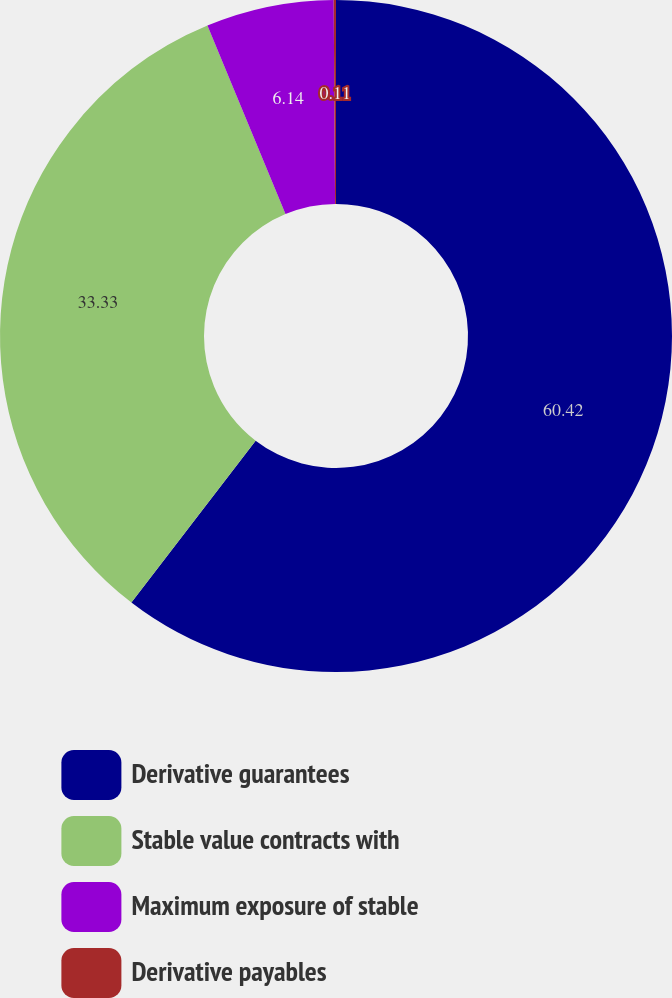<chart> <loc_0><loc_0><loc_500><loc_500><pie_chart><fcel>Derivative guarantees<fcel>Stable value contracts with<fcel>Maximum exposure of stable<fcel>Derivative payables<nl><fcel>60.42%<fcel>33.33%<fcel>6.14%<fcel>0.11%<nl></chart> 